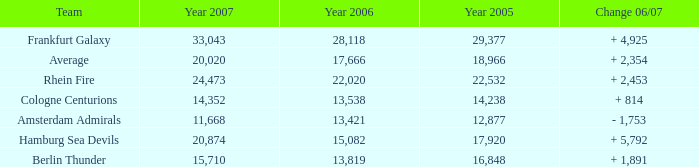What is the sum of Year 2007(s), when the Year 2005 is greater than 29,377? None. 